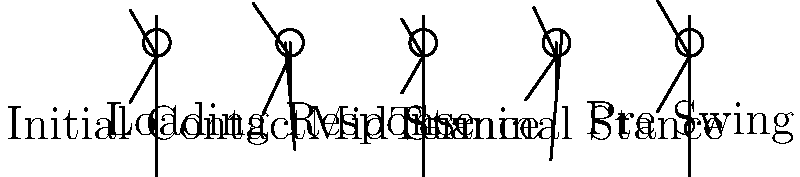In the gait cycle illustration, which phase demonstrates the greatest potential for energy storage in the Achilles tendon, and why is this important for efficient locomotion? To answer this question, we need to analyze each phase of the gait cycle and understand the biomechanics involved:

1. Initial Contact: The heel strikes the ground, but there's minimal stretch in the Achilles tendon.

2. Loading Response: Weight is transferred to the stance leg, but the Achilles tendon is not yet fully engaged.

3. Mid Stance: The body moves over the planted foot, but the Achilles tendon is not maximally stretched.

4. Terminal Stance: This phase shows the greatest dorsiflexion of the ankle, which means the Achilles tendon is maximally stretched. This stretch stores elastic energy in the tendon.

5. Pre Swing: The stored energy begins to be released as the foot pushes off the ground.

The Terminal Stance phase demonstrates the greatest potential for energy storage in the Achilles tendon. This is important for efficient locomotion because:

1. Energy Conservation: The stretched tendon stores elastic energy, which is then released during push-off, reducing the muscular effort required.

2. Power Generation: The release of stored energy contributes to the power needed for propulsion in the next step.

3. Metabolic Efficiency: By utilizing elastic energy storage and return, the body reduces the overall metabolic cost of walking or running.

4. Speed and Performance: The stretch-shortening cycle of the Achilles tendon contributes to faster and more powerful movements in activities like sprinting.

This mechanism is a key example of how the human body has evolved for efficient bipedal locomotion.
Answer: Terminal Stance; maximizes elastic energy storage for efficient propulsion 